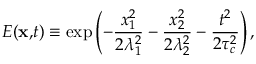Convert formula to latex. <formula><loc_0><loc_0><loc_500><loc_500>E ( x , t ) \equiv \exp \left ( - \frac { x _ { 1 } ^ { 2 } } { 2 \lambda _ { 1 } ^ { 2 } } - \frac { x _ { 2 } ^ { 2 } } { 2 \lambda _ { 2 } ^ { 2 } } - \frac { t ^ { 2 } } { 2 \tau _ { c } ^ { 2 } } \right ) ,</formula> 